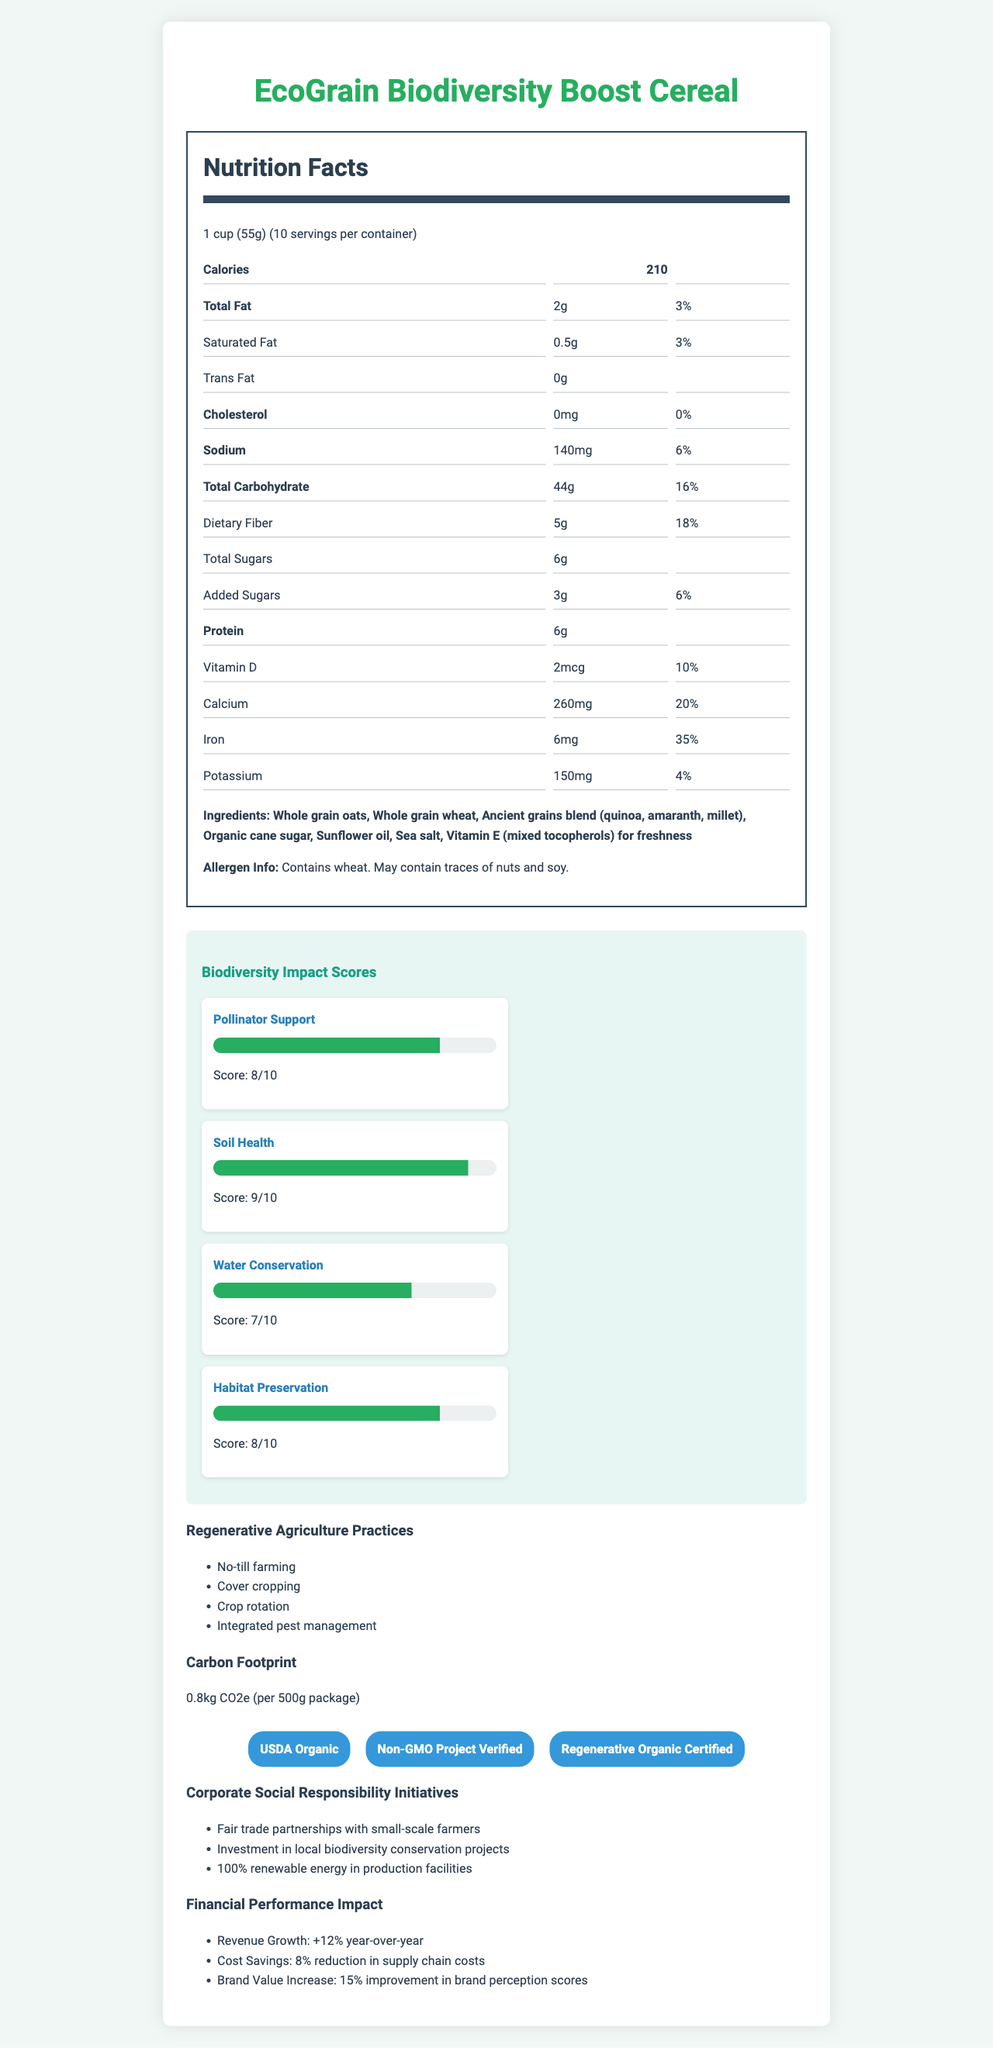what is the serving size of EcoGrain Biodiversity Boost Cereal? The serving size is listed at the beginning of the Nutrition Facts section as "1 cup (55g)."
Answer: 1 cup (55g) how many servings are there per container? The number of servings per container is mentioned right next to the serving size and is stated as "10."
Answer: 10 what is the total fat content per serving? The total fat content is listed under the nutrition facts section as "Total Fat: 2g."
Answer: 2g how much vitamin D is in one serving of this cereal? The amount of vitamin D is listed under the nutrition facts section as "Vitamin D: 2mcg."
Answer: 2mcg what is the carbon footprint of the cereal per 500g package? The carbon footprint is specified in the Carbon Footprint section as "0.8kg CO2e per 500g package."
Answer: 0.8kg CO2e what are the regenerative agriculture practices mentioned? The regenerative agriculture practices are listed in the section titled "Regenerative Agriculture Practices."
Answer: No-till farming, Cover cropping, Crop rotation, Integrated pest management choose the correct daily value percentage for dietary fiber per serving: A. 15% B. 18% C. 20% D. 25% The daily value percentage for dietary fiber is listed under "Dietary Fiber" in the nutrition facts section as "18%."
Answer: B. 18% which of the following certifications is NOT mentioned on the document? A. USDA Organic B. Non-GMO Project Verified C. Fair Trade Certified D. Regenerative Organic Certified The certifications listed are USDA Organic, Non-GMO Project Verified, and Regenerative Organic Certified.
Answer: C. Fair Trade Certified is this product free of trans fat? The amount of trans fat is listed as "0g," indicating there is no trans fat in the product.
Answer: Yes summarize the main features and benefits of the EcoGrain Biodiversity Boost Cereal. The main features include its nutritious composition and the use of regenerative agriculture practices, resulting in high biodiversity impact scores. It is certified by notable organizations and contributes positively to financial performance. The cereal is socially responsible and environmentally friendly, emphasizing health benefits and sustainability.
Answer: The EcoGrain Biodiversity Boost Cereal is a regenerative agriculture product with a strong focus on biodiversity impact and health benefits. It contains nutritious ingredients like whole grains and ancient grains. The cereal has received high biodiversity impact scores in pollinator support, soil health, water conservation, and habitat preservation. It supports various regenerative agriculture practices like no-till farming and crop rotation. The product holds certifications such as USDA Organic and Non-GMO Project Verified and demonstrates positive financial performance, including revenue growth and cost savings. Additionally, it engages in corporate social responsibility initiatives such as fair trade partnerships and investment in local biodiversity projects. how much has the brand value increased according to the document? The brand value increase is listed in the "Financial Performance Impact" section as "15% improvement in brand perception scores."
Answer: 15% how much sodium is in one serving of this cereal? The sodium content is listed under the nutrition facts section as "Sodium: 140mg."
Answer: 140mg what are the main ingredients of the cereal? The main ingredients are detailed in the ingredients section.
Answer: Whole grain oats, Whole grain wheat, Ancient grains blend (quinoa, amaranth, millet), Organic cane sugar, Sunflower oil, Sea salt, Vitamin E (mixed tocopherols) for freshness identify the allergen information provided for the product. The allergen information is listed at the end of the ingredients section.
Answer: Contains wheat. May contain traces of nuts and soy. what impacts does the cereal have on biodiversity? These scores are detailed in the "Biodiversity Impact Scores" section and show the cereal's positive impacts on different environmental factors.
Answer: High impact on pollinator support, soil health, water conservation, and habitat preservation with scores of 8, 9, 7, and 8 respectively. what percentage of renewable energy is used in production facilities? The document states "100% renewable energy in production facilities" under the corporate social responsibility initiatives.
Answer: 100% which age group is most likely to benefit from this cereal? The document does not provide any specific data or references to age groups that this cereal targets or benefits specifically.
Answer: Not enough information 